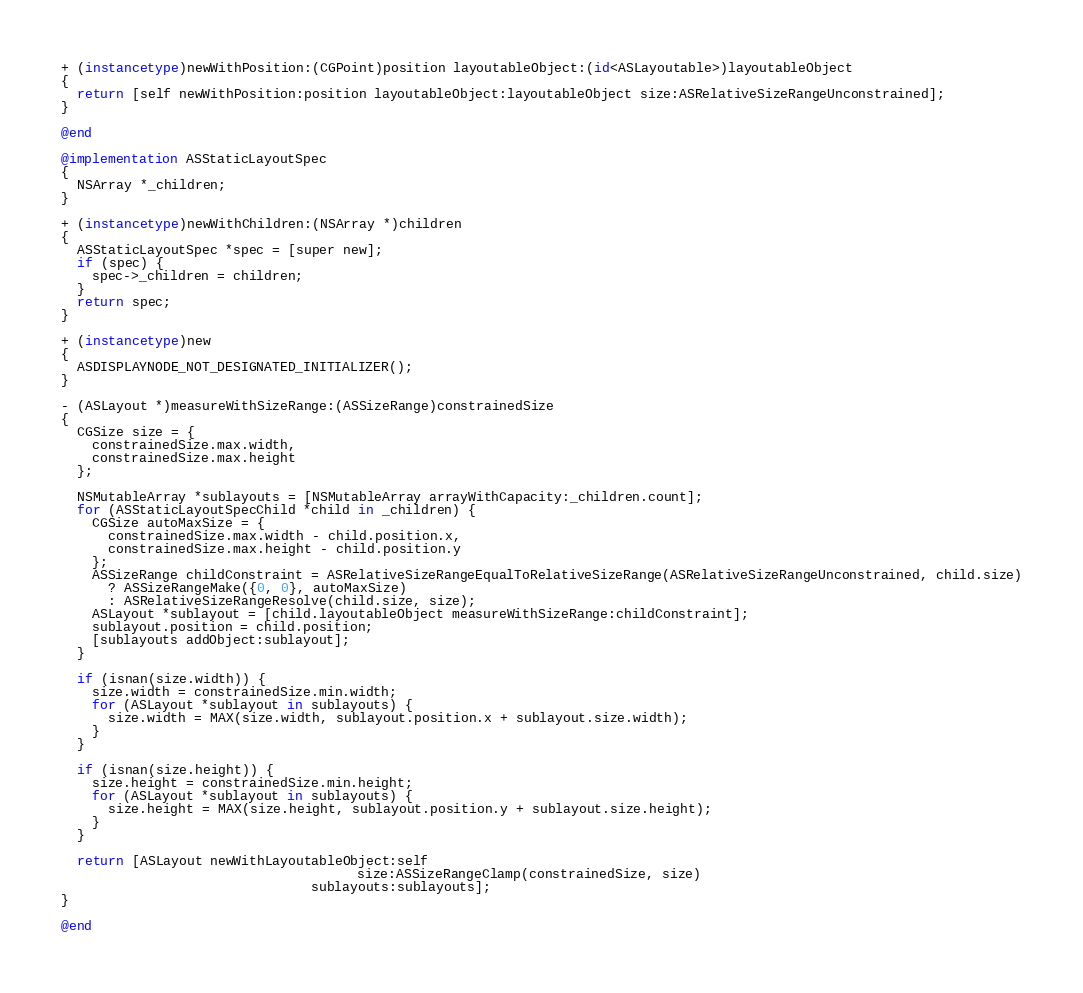Convert code to text. <code><loc_0><loc_0><loc_500><loc_500><_ObjectiveC_>+ (instancetype)newWithPosition:(CGPoint)position layoutableObject:(id<ASLayoutable>)layoutableObject
{
  return [self newWithPosition:position layoutableObject:layoutableObject size:ASRelativeSizeRangeUnconstrained];
}

@end

@implementation ASStaticLayoutSpec
{
  NSArray *_children;
}

+ (instancetype)newWithChildren:(NSArray *)children
{
  ASStaticLayoutSpec *spec = [super new];
  if (spec) {
    spec->_children = children;
  }
  return spec;
}

+ (instancetype)new
{
  ASDISPLAYNODE_NOT_DESIGNATED_INITIALIZER();
}

- (ASLayout *)measureWithSizeRange:(ASSizeRange)constrainedSize
{
  CGSize size = {
    constrainedSize.max.width,
    constrainedSize.max.height
  };

  NSMutableArray *sublayouts = [NSMutableArray arrayWithCapacity:_children.count];
  for (ASStaticLayoutSpecChild *child in _children) {
    CGSize autoMaxSize = {
      constrainedSize.max.width - child.position.x,
      constrainedSize.max.height - child.position.y
    };
    ASSizeRange childConstraint = ASRelativeSizeRangeEqualToRelativeSizeRange(ASRelativeSizeRangeUnconstrained, child.size)
      ? ASSizeRangeMake({0, 0}, autoMaxSize)
      : ASRelativeSizeRangeResolve(child.size, size);
    ASLayout *sublayout = [child.layoutableObject measureWithSizeRange:childConstraint];
    sublayout.position = child.position;
    [sublayouts addObject:sublayout];
  }
  
  if (isnan(size.width)) {
    size.width = constrainedSize.min.width;
    for (ASLayout *sublayout in sublayouts) {
      size.width = MAX(size.width, sublayout.position.x + sublayout.size.width);
    }
  }

  if (isnan(size.height)) {
    size.height = constrainedSize.min.height;
    for (ASLayout *sublayout in sublayouts) {
      size.height = MAX(size.height, sublayout.position.y + sublayout.size.height);
    }
  }

  return [ASLayout newWithLayoutableObject:self
                                      size:ASSizeRangeClamp(constrainedSize, size)
                                sublayouts:sublayouts];
}

@end
</code> 